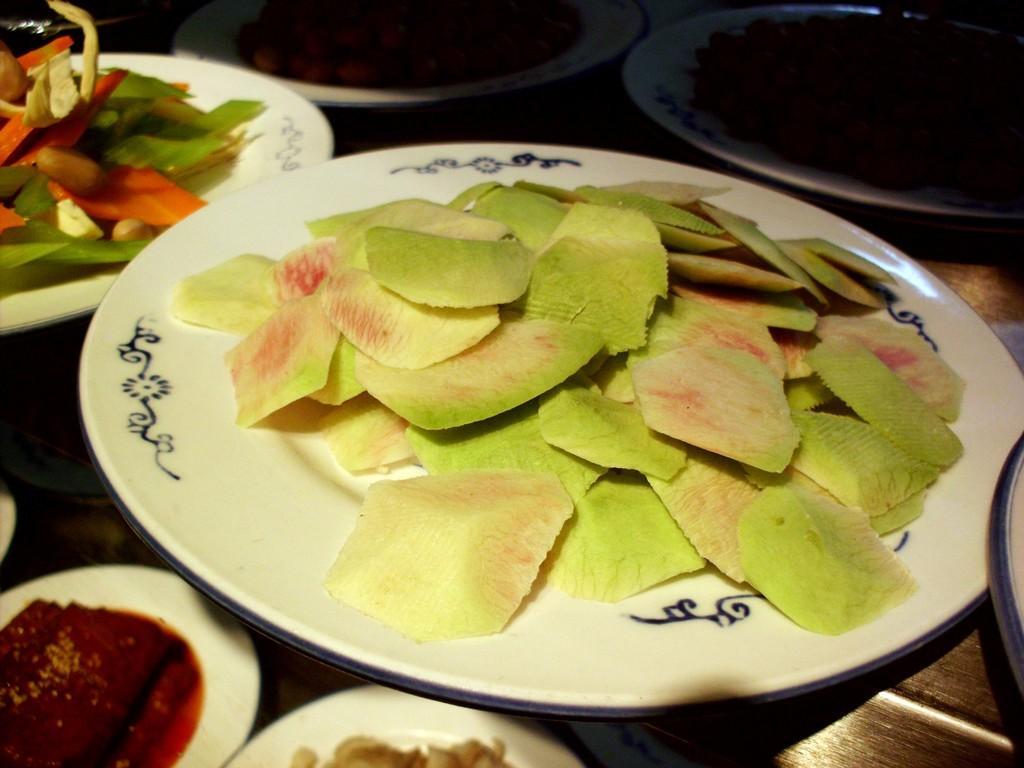Can you describe this image briefly? In this picture I can observe slices of a fruit placed in the white color plate. I can observe some vegetables beside this plate, placed in the another plate. These plates are placed on the table. 